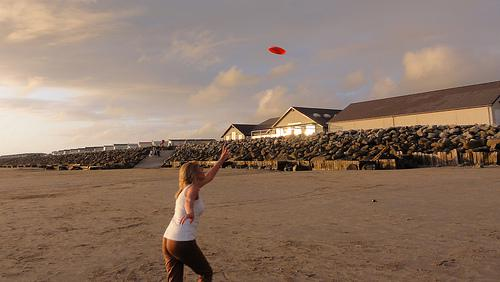Question: where is the woman?
Choices:
A. By the lake.
B. In the forest.
C. On the beach.
D. Near the mountains.
Answer with the letter. Answer: C Question: why is the woman running?
Choices:
A. To catch a baseball.
B. To score a goal.
C. To catch the frisbee.
D. To kick a ball.
Answer with the letter. Answer: C Question: who is in the photo?
Choices:
A. A man.
B. A child.
C. A woman.
D. A teenager.
Answer with the letter. Answer: C Question: when was the photo taken?
Choices:
A. Dawn.
B. Day.
C. Dusk.
D. Night.
Answer with the letter. Answer: C 